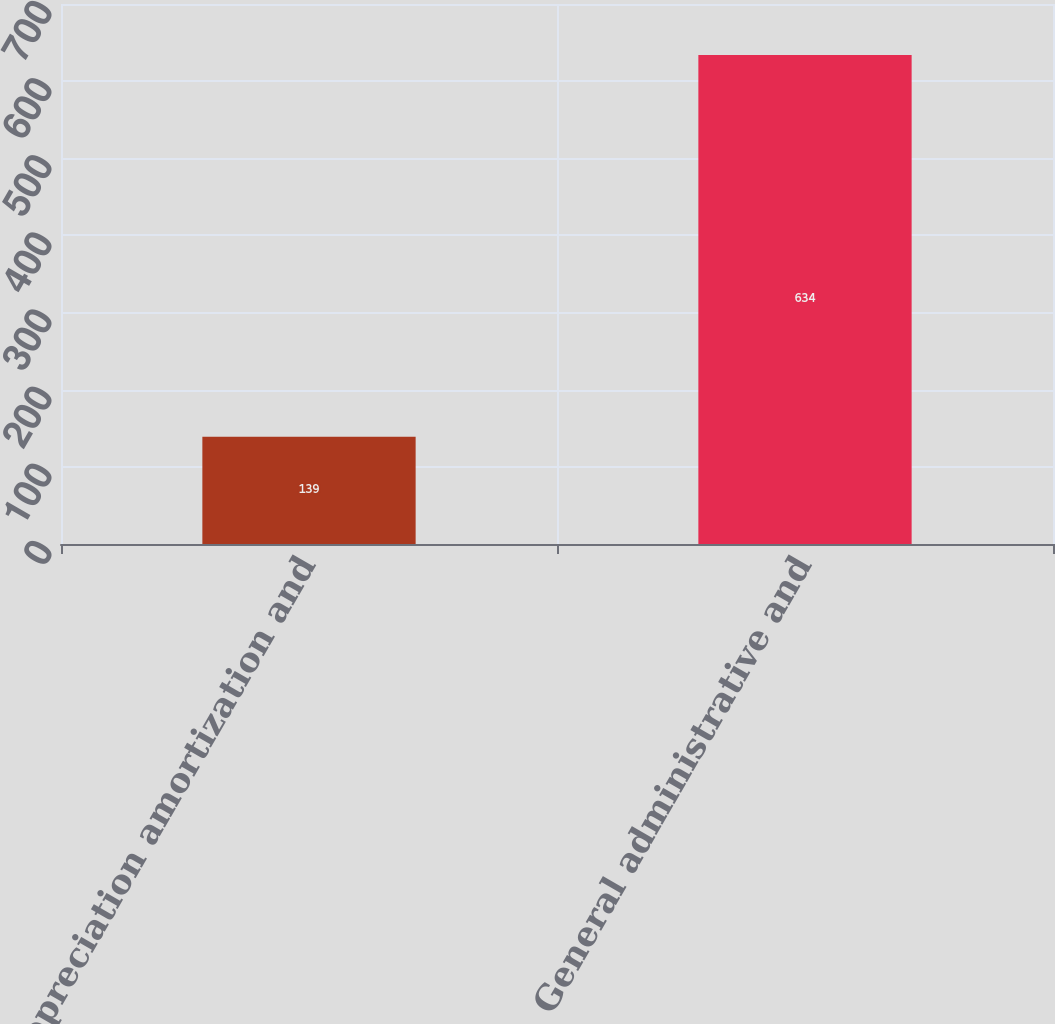<chart> <loc_0><loc_0><loc_500><loc_500><bar_chart><fcel>Depreciation amortization and<fcel>General administrative and<nl><fcel>139<fcel>634<nl></chart> 